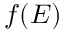Convert formula to latex. <formula><loc_0><loc_0><loc_500><loc_500>f ( E )</formula> 